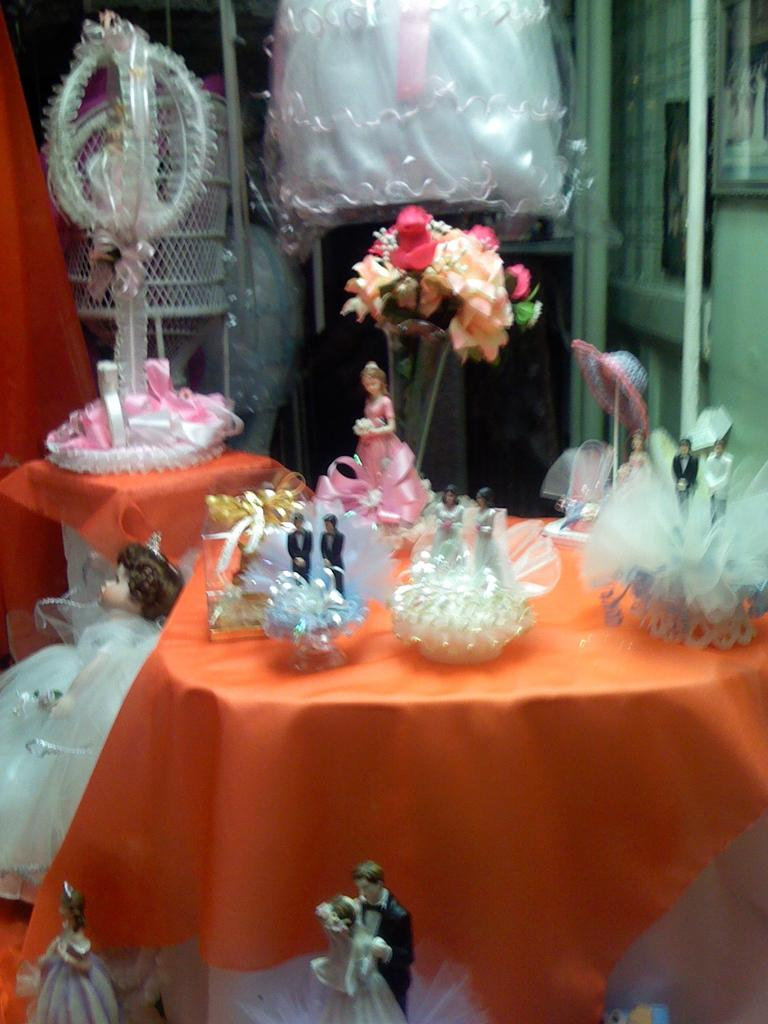What types of toys are in the image? There are colorful dolls in the image. What animals are in the image? There are dogs in the image. Where are the dolls and dogs located in the image? Both dolls and dogs are present on a table. What type of popcorn is being served in the image? There is no popcorn present in the image. Can you tell me how many eggs are in the eggnog being served in the image? There is no eggnog or eggs present in the image. 